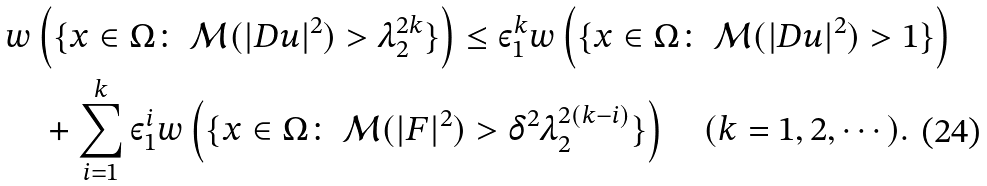<formula> <loc_0><loc_0><loc_500><loc_500>& w \left ( \{ x \in \Omega \colon \ \mathcal { M } ( | D u | ^ { 2 } ) > \lambda _ { 2 } ^ { 2 k } \} \right ) \leq \varepsilon _ { 1 } ^ { k } w \left ( \{ x \in \Omega \colon \ \mathcal { M } ( | D u | ^ { 2 } ) > 1 \} \right ) \\ & \quad + \sum ^ { k } _ { i = 1 } \varepsilon _ { 1 } ^ { i } w \left ( \{ x \in \Omega \colon \ \mathcal { M } ( | F | ^ { 2 } ) > \delta ^ { 2 } \lambda _ { 2 } ^ { 2 ( k - i ) } \} \right ) \quad ( k = 1 , 2 , \cdots ) .</formula> 